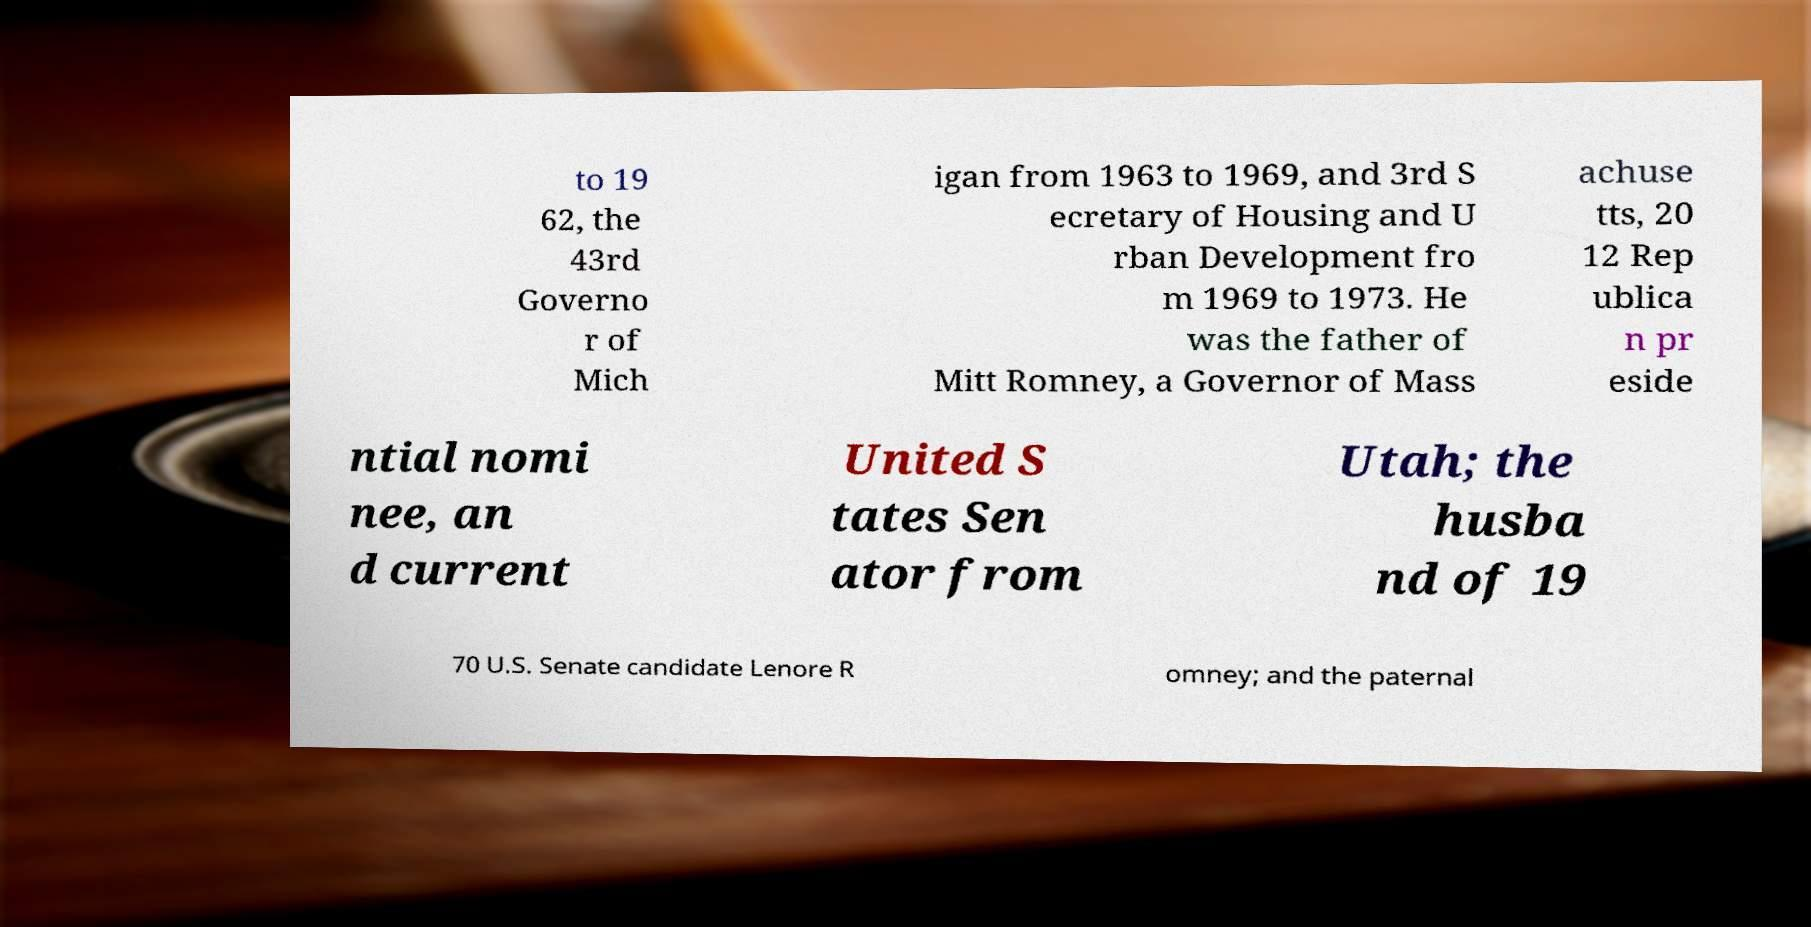Please read and relay the text visible in this image. What does it say? to 19 62, the 43rd Governo r of Mich igan from 1963 to 1969, and 3rd S ecretary of Housing and U rban Development fro m 1969 to 1973. He was the father of Mitt Romney, a Governor of Mass achuse tts, 20 12 Rep ublica n pr eside ntial nomi nee, an d current United S tates Sen ator from Utah; the husba nd of 19 70 U.S. Senate candidate Lenore R omney; and the paternal 